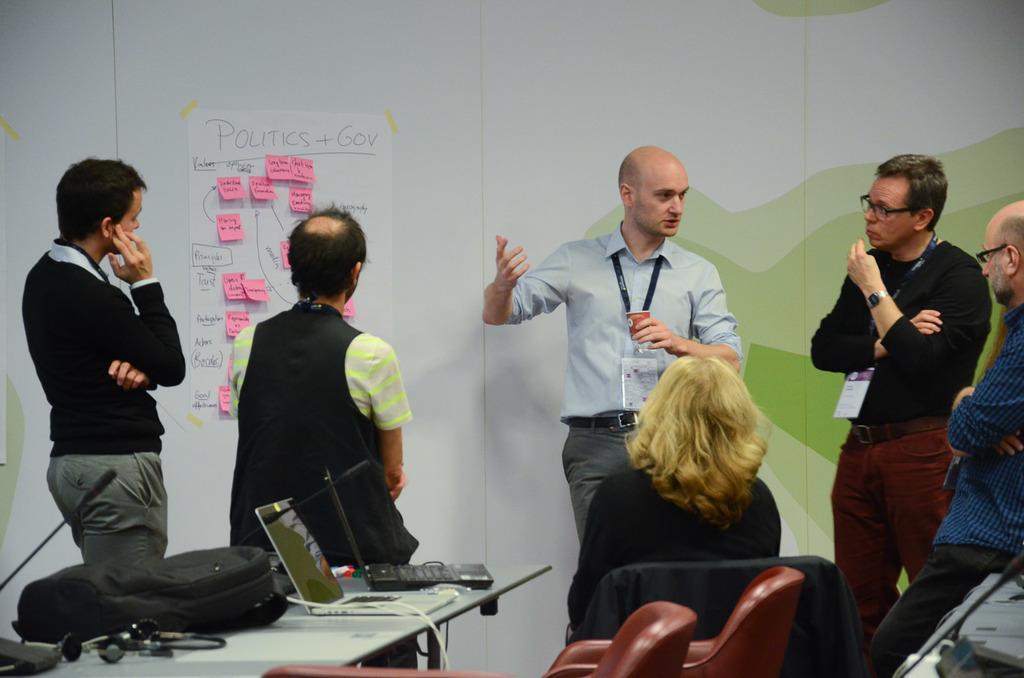In one or two sentences, can you explain what this image depicts? In the background we can see the wall. We can see a paper on the wall. There is some information on a white paper and stick notes. In this picture we can see people standing and looks like they are discussing. On the left side of the picture on a table we can see backpack, laptops, headsets and a microphone. At the bottom portion of the picture we can see chairs. We can see a woman is sitting on a chair. 